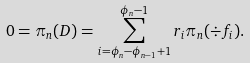<formula> <loc_0><loc_0><loc_500><loc_500>0 = \pi _ { n } ( D ) = \sum _ { i = \phi _ { n } - \phi _ { n - 1 } + 1 } ^ { \phi _ { n } - 1 } r _ { i } \pi _ { n } ( \div f _ { i } ) .</formula> 